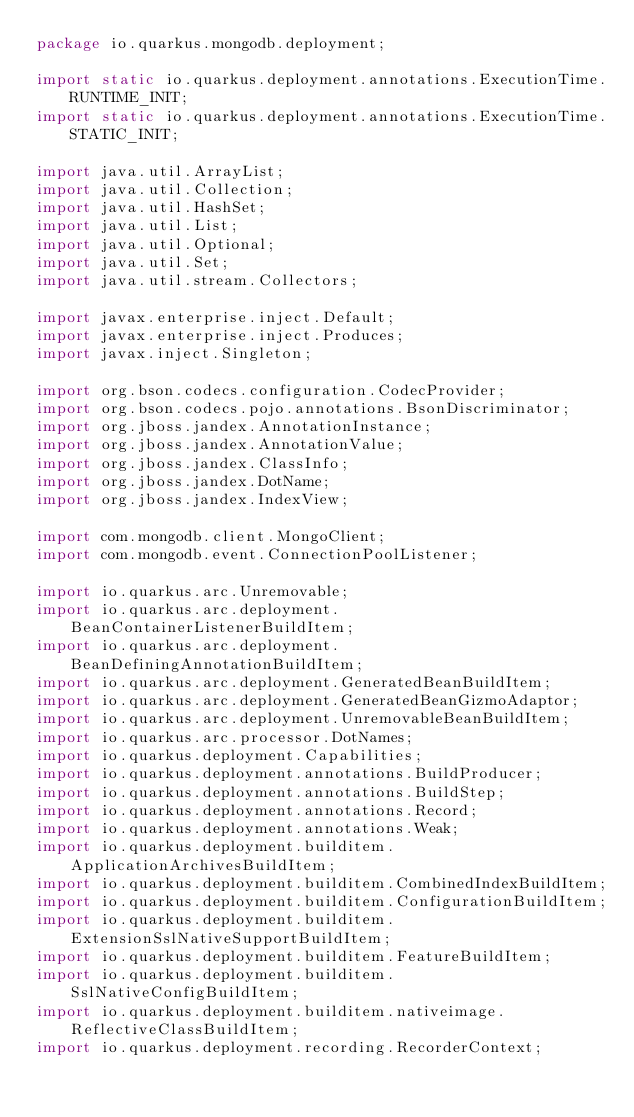<code> <loc_0><loc_0><loc_500><loc_500><_Java_>package io.quarkus.mongodb.deployment;

import static io.quarkus.deployment.annotations.ExecutionTime.RUNTIME_INIT;
import static io.quarkus.deployment.annotations.ExecutionTime.STATIC_INIT;

import java.util.ArrayList;
import java.util.Collection;
import java.util.HashSet;
import java.util.List;
import java.util.Optional;
import java.util.Set;
import java.util.stream.Collectors;

import javax.enterprise.inject.Default;
import javax.enterprise.inject.Produces;
import javax.inject.Singleton;

import org.bson.codecs.configuration.CodecProvider;
import org.bson.codecs.pojo.annotations.BsonDiscriminator;
import org.jboss.jandex.AnnotationInstance;
import org.jboss.jandex.AnnotationValue;
import org.jboss.jandex.ClassInfo;
import org.jboss.jandex.DotName;
import org.jboss.jandex.IndexView;

import com.mongodb.client.MongoClient;
import com.mongodb.event.ConnectionPoolListener;

import io.quarkus.arc.Unremovable;
import io.quarkus.arc.deployment.BeanContainerListenerBuildItem;
import io.quarkus.arc.deployment.BeanDefiningAnnotationBuildItem;
import io.quarkus.arc.deployment.GeneratedBeanBuildItem;
import io.quarkus.arc.deployment.GeneratedBeanGizmoAdaptor;
import io.quarkus.arc.deployment.UnremovableBeanBuildItem;
import io.quarkus.arc.processor.DotNames;
import io.quarkus.deployment.Capabilities;
import io.quarkus.deployment.annotations.BuildProducer;
import io.quarkus.deployment.annotations.BuildStep;
import io.quarkus.deployment.annotations.Record;
import io.quarkus.deployment.annotations.Weak;
import io.quarkus.deployment.builditem.ApplicationArchivesBuildItem;
import io.quarkus.deployment.builditem.CombinedIndexBuildItem;
import io.quarkus.deployment.builditem.ConfigurationBuildItem;
import io.quarkus.deployment.builditem.ExtensionSslNativeSupportBuildItem;
import io.quarkus.deployment.builditem.FeatureBuildItem;
import io.quarkus.deployment.builditem.SslNativeConfigBuildItem;
import io.quarkus.deployment.builditem.nativeimage.ReflectiveClassBuildItem;
import io.quarkus.deployment.recording.RecorderContext;</code> 